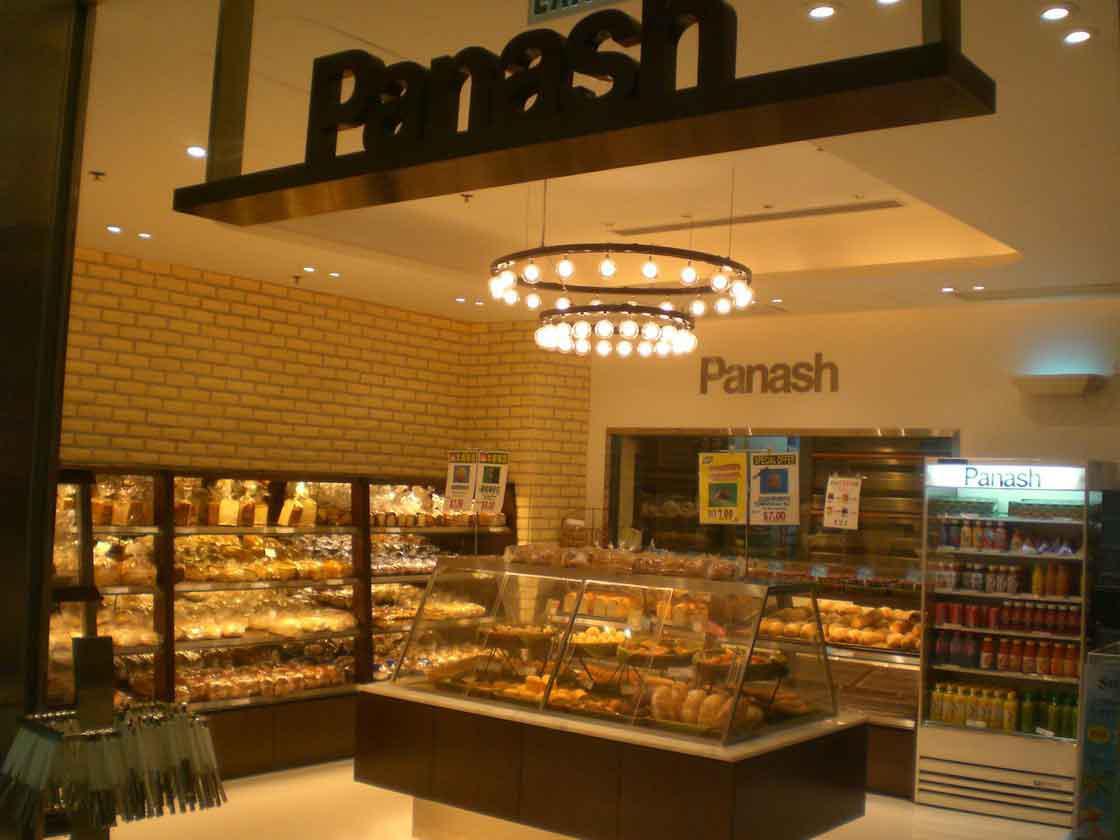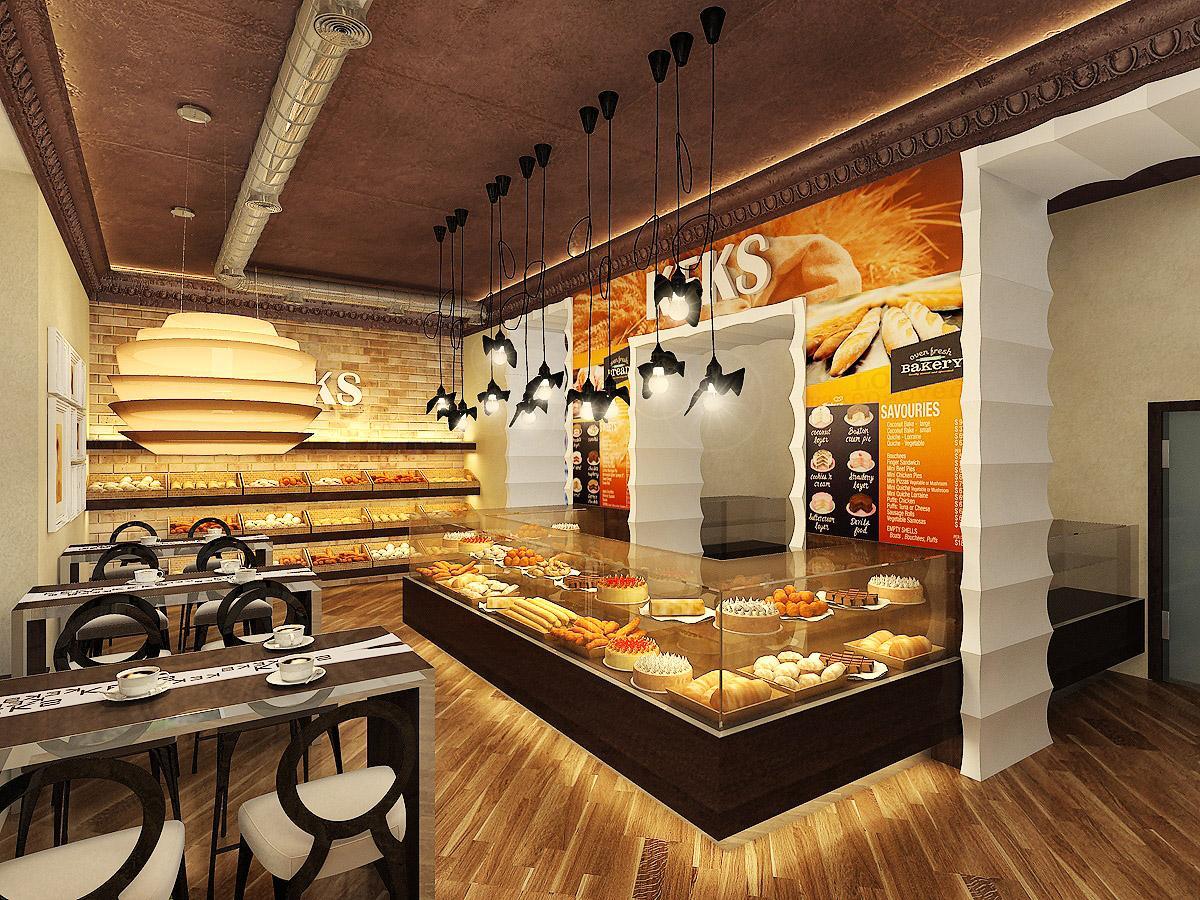The first image is the image on the left, the second image is the image on the right. Evaluate the accuracy of this statement regarding the images: "there are chairs in the image on the right.". Is it true? Answer yes or no. Yes. The first image is the image on the left, the second image is the image on the right. Considering the images on both sides, is "One image shows a food establishment with a geometric pattern, black and white floor." valid? Answer yes or no. No. 